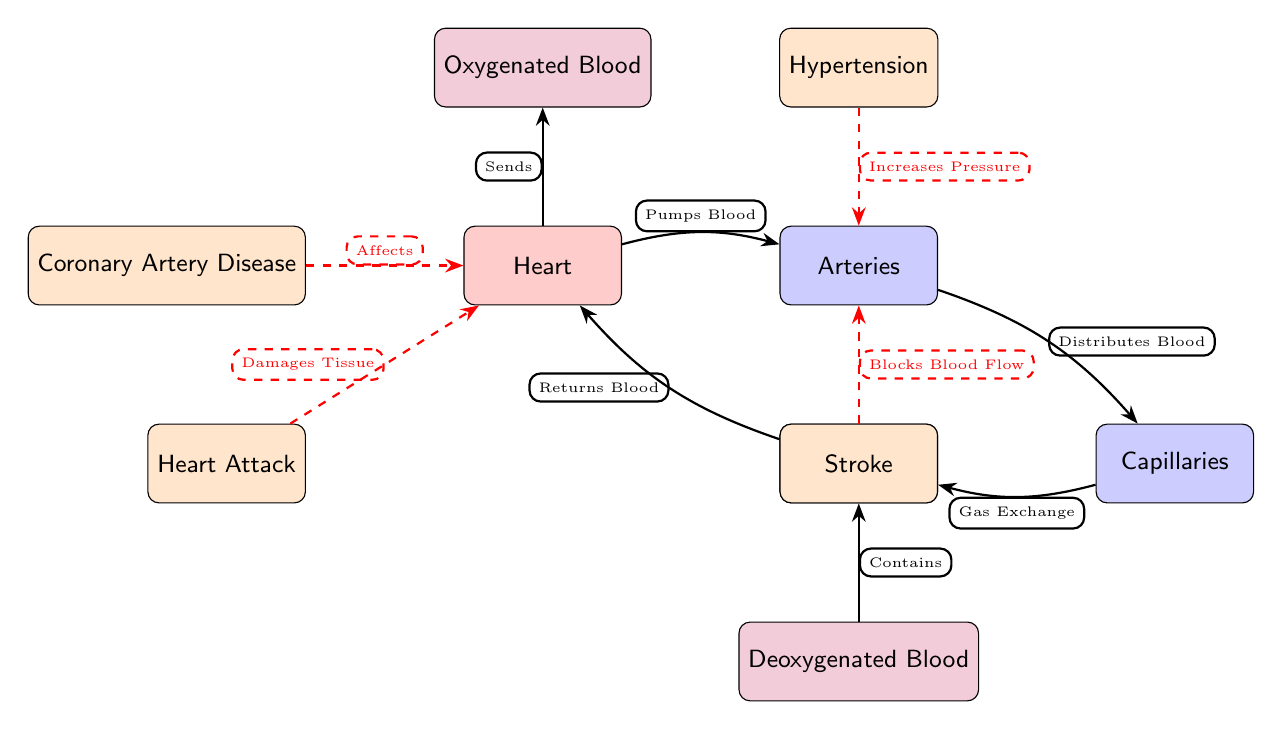What organ is represented at the center of the diagram? The diagram illustrates the heart as the central organ, indicated by its position at the center and designated with the label "Heart."
Answer: Heart How many diseases are depicted in the diagram? The diagram shows a total of four diseases: Coronary Artery Disease, Hypertension, Heart Attack, and Stroke. This count can be confirmed by counting the disease nodes on the left and upper sides of the heart.
Answer: 4 What type of blood does the heart send to the arteries? The diagram indicates that the heart sends oxygenated blood to the arteries, confirmed by the flow arrow and label from the heart pointing towards the oxygenated blood node.
Answer: Oxygenated Blood Which disease affects the heart directly? The diagram identifies Coronary Artery Disease as affecting the heart, which is indicated by the connection labeled "Affects" that points from the disease node to the heart node.
Answer: Coronary Artery Disease What is the function of veins depicted in the diagram? The diagram shows that veins return blood to the heart, as indicated by the flow arrow directed from the veins back to the heart, accompanied by the labeled description "Returns Blood."
Answer: Returns Blood How does hypertension impact the arteries? According to the diagram, hypertension increases pressure in the arteries, as evidenced by the flow relationship labeled "Increases Pressure" connecting hypertension to the arteries.
Answer: Increases Pressure Which organ receives deoxygenated blood? The diagram states that veins contain deoxygenated blood, which is indicated by the arrow showing the link from deoxygenated blood to the veins labeled "Contains."
Answer: Veins What is the process that occurs in capillaries? The diagram specifies that gas exchange occurs in capillaries, as shown by the flow labeled "Gas Exchange" moving from capillaries to veins.
Answer: Gas Exchange What blocks blood flow according to the diagram? The diagram indicates that a stroke blocks blood flow, as this is shown with the flow labeled "Blocks Blood Flow," directed from the stroke disease node to the arteries.
Answer: Stroke 